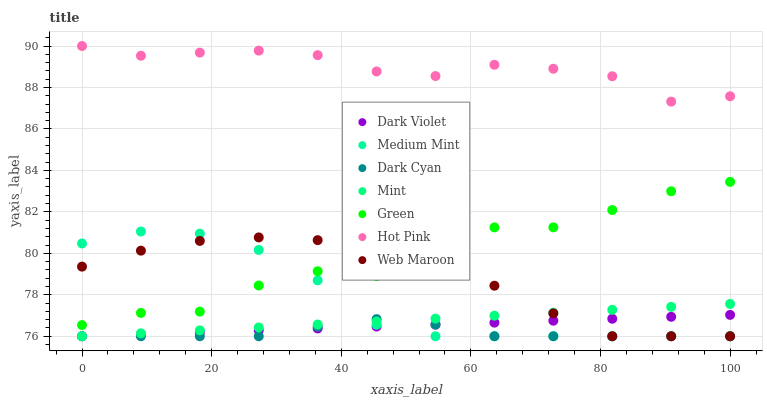Does Dark Cyan have the minimum area under the curve?
Answer yes or no. Yes. Does Hot Pink have the maximum area under the curve?
Answer yes or no. Yes. Does Web Maroon have the minimum area under the curve?
Answer yes or no. No. Does Web Maroon have the maximum area under the curve?
Answer yes or no. No. Is Dark Violet the smoothest?
Answer yes or no. Yes. Is Green the roughest?
Answer yes or no. Yes. Is Hot Pink the smoothest?
Answer yes or no. No. Is Hot Pink the roughest?
Answer yes or no. No. Does Medium Mint have the lowest value?
Answer yes or no. Yes. Does Hot Pink have the lowest value?
Answer yes or no. No. Does Hot Pink have the highest value?
Answer yes or no. Yes. Does Web Maroon have the highest value?
Answer yes or no. No. Is Web Maroon less than Hot Pink?
Answer yes or no. Yes. Is Hot Pink greater than Green?
Answer yes or no. Yes. Does Green intersect Medium Mint?
Answer yes or no. Yes. Is Green less than Medium Mint?
Answer yes or no. No. Is Green greater than Medium Mint?
Answer yes or no. No. Does Web Maroon intersect Hot Pink?
Answer yes or no. No. 